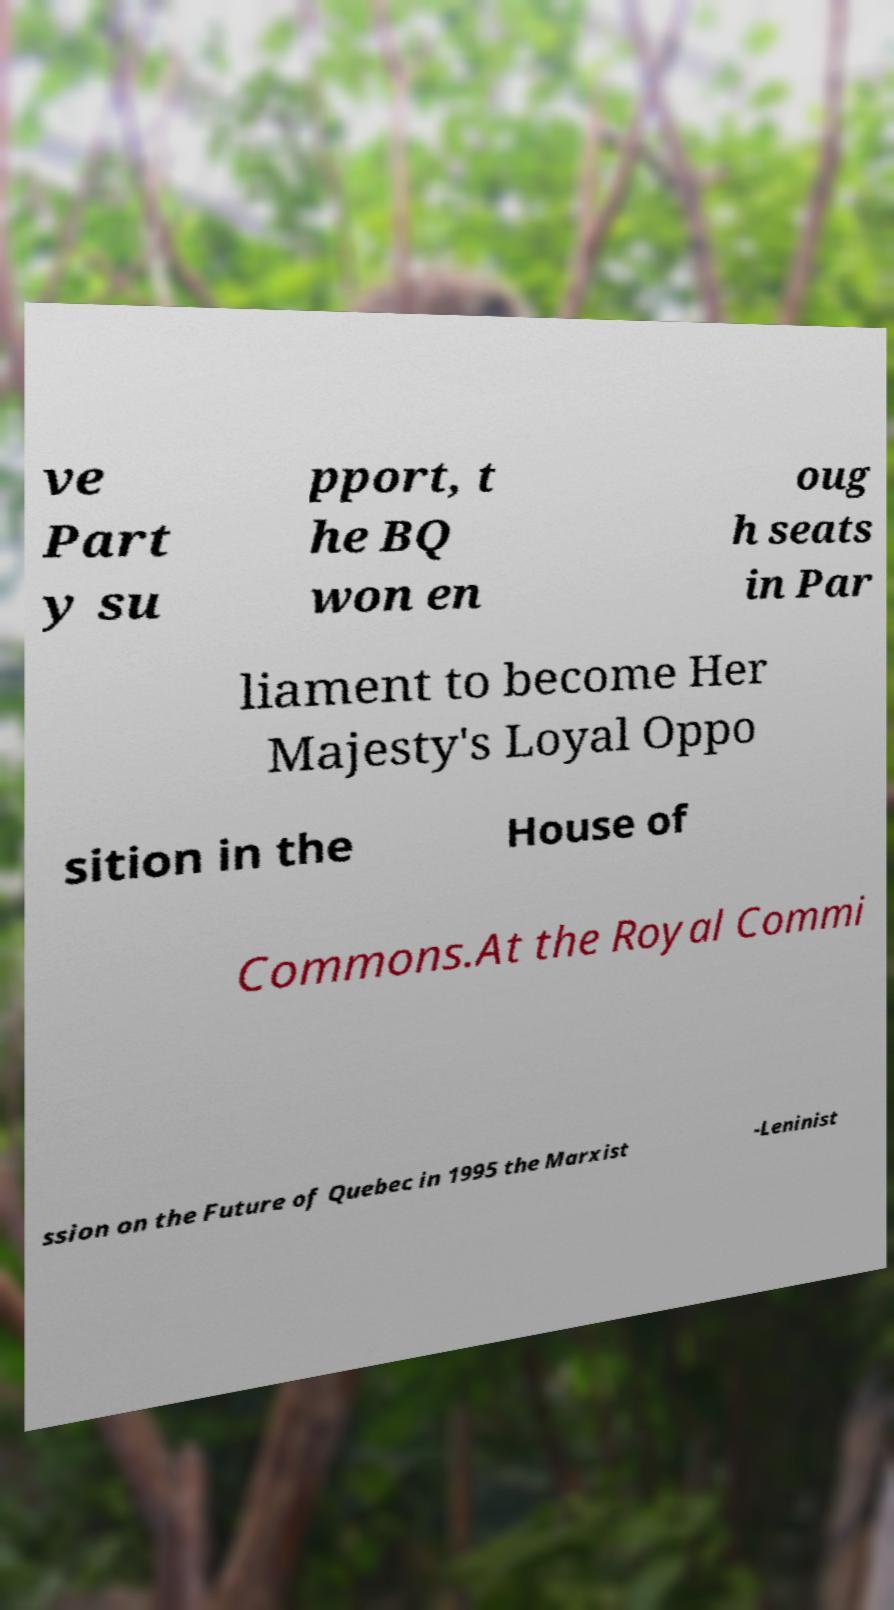Can you read and provide the text displayed in the image?This photo seems to have some interesting text. Can you extract and type it out for me? ve Part y su pport, t he BQ won en oug h seats in Par liament to become Her Majesty's Loyal Oppo sition in the House of Commons.At the Royal Commi ssion on the Future of Quebec in 1995 the Marxist -Leninist 